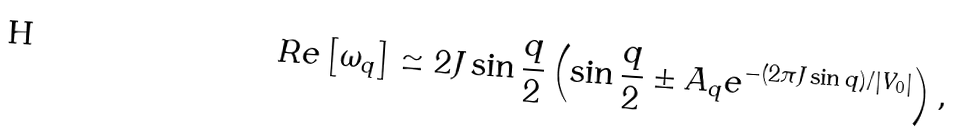Convert formula to latex. <formula><loc_0><loc_0><loc_500><loc_500>R e \left [ \omega _ { q } \right ] \simeq 2 J \sin \frac { q } { 2 } \left ( \sin \frac { q } { 2 } \pm A _ { q } e ^ { - ( 2 \pi J \sin q ) / | V _ { 0 } | } \right ) ,</formula> 